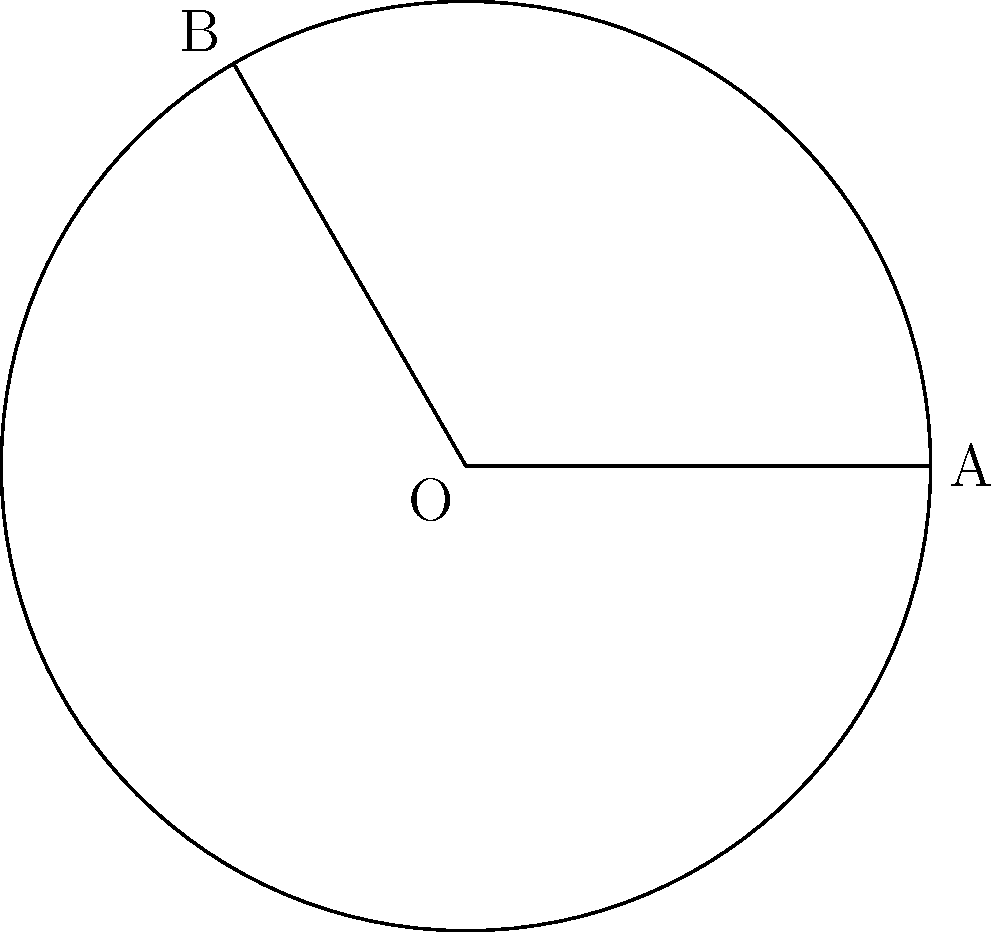In a circular data storage system, sensitive patient information is partitioned into segments for enhanced privacy. Consider a circular segment with central angle $\frac{2\pi}{3}$ radians in a circle of radius 3 units. Calculate the area of this segment to determine the proportion of data stored in this partition. Round your answer to two decimal places. To find the area of the circular segment, we need to follow these steps:

1) The area of a circular segment is given by the formula:
   $$A_{segment} = A_{sector} - A_{triangle}$$

2) Area of the sector:
   $$A_{sector} = \frac{1}{2}r^2\theta$$
   Where $r = 3$ and $\theta = \frac{2\pi}{3}$
   $$A_{sector} = \frac{1}{2} \cdot 3^2 \cdot \frac{2\pi}{3} = 3\pi$$

3) Area of the triangle:
   $$A_{triangle} = \frac{1}{2}r^2\sin\theta$$
   $$A_{triangle} = \frac{1}{2} \cdot 3^2 \cdot \sin(\frac{2\pi}{3}) = \frac{9\sqrt{3}}{4}$$

4) Now, we can calculate the area of the segment:
   $$A_{segment} = A_{sector} - A_{triangle}$$
   $$A_{segment} = 3\pi - \frac{9\sqrt{3}}{4}$$

5) Evaluating and rounding to two decimal places:
   $$A_{segment} \approx 5.89$$

This area represents the proportion of data stored in this partition of the circular storage system.
Answer: 5.89 square units 